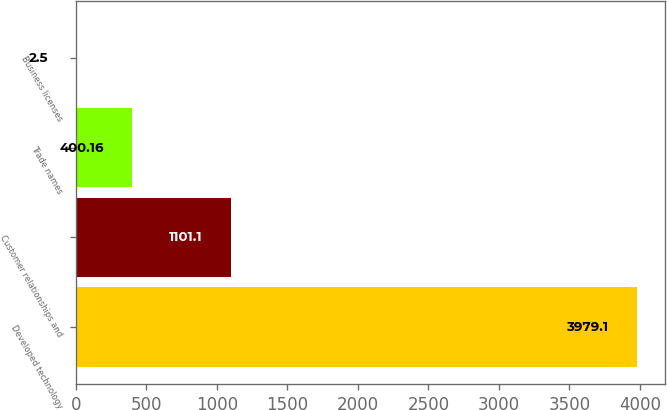<chart> <loc_0><loc_0><loc_500><loc_500><bar_chart><fcel>Developed technology<fcel>Customer relationships and<fcel>Trade names<fcel>Business licenses<nl><fcel>3979.1<fcel>1101.1<fcel>400.16<fcel>2.5<nl></chart> 